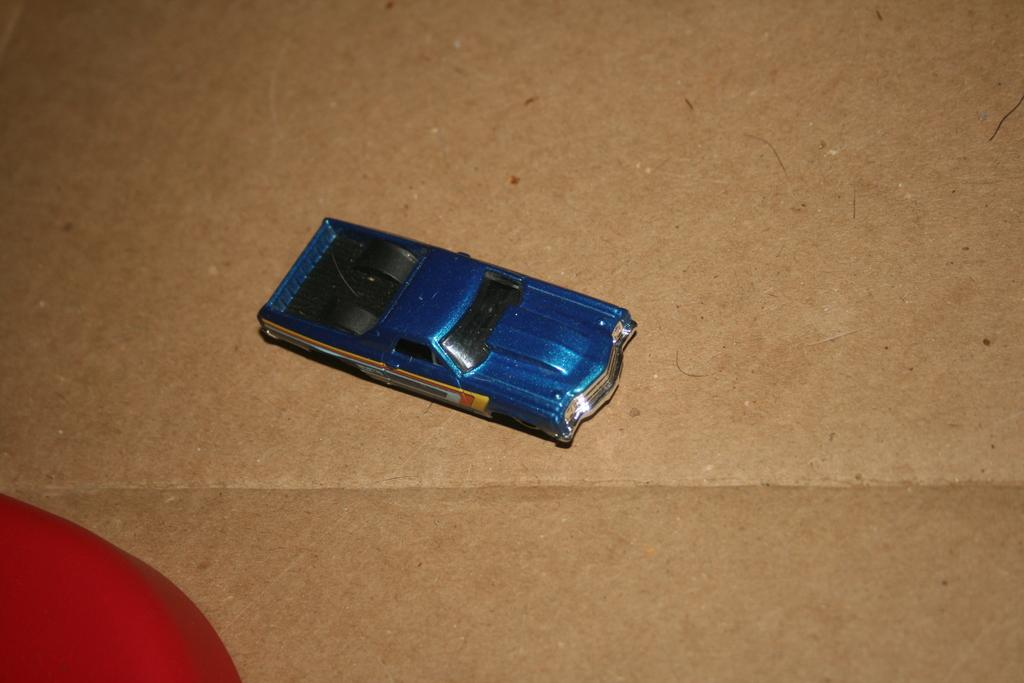What is the main subject of the image? The main subject of the image is a toy car. Where is the toy car located in the image? The toy car is on the floor. What is the color of an object that is visible in the image? There is a red color object in the image. How is the red color object positioned in relation to the toy car? The red color object is beside the toy car. Can you tell me how the police are involved in the image? There is no mention of police in the image; it features a toy car on the floor with a red object beside it. What type of motion is the car exhibiting in the image? The image is a still photograph, so the car is not exhibiting any motion. 